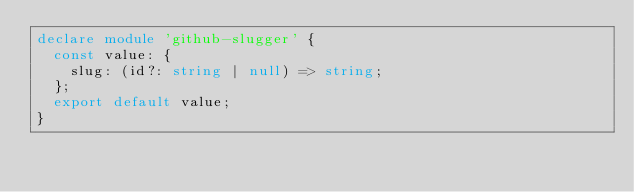<code> <loc_0><loc_0><loc_500><loc_500><_TypeScript_>declare module 'github-slugger' {
  const value: {
    slug: (id?: string | null) => string;
  };
  export default value;
}
</code> 